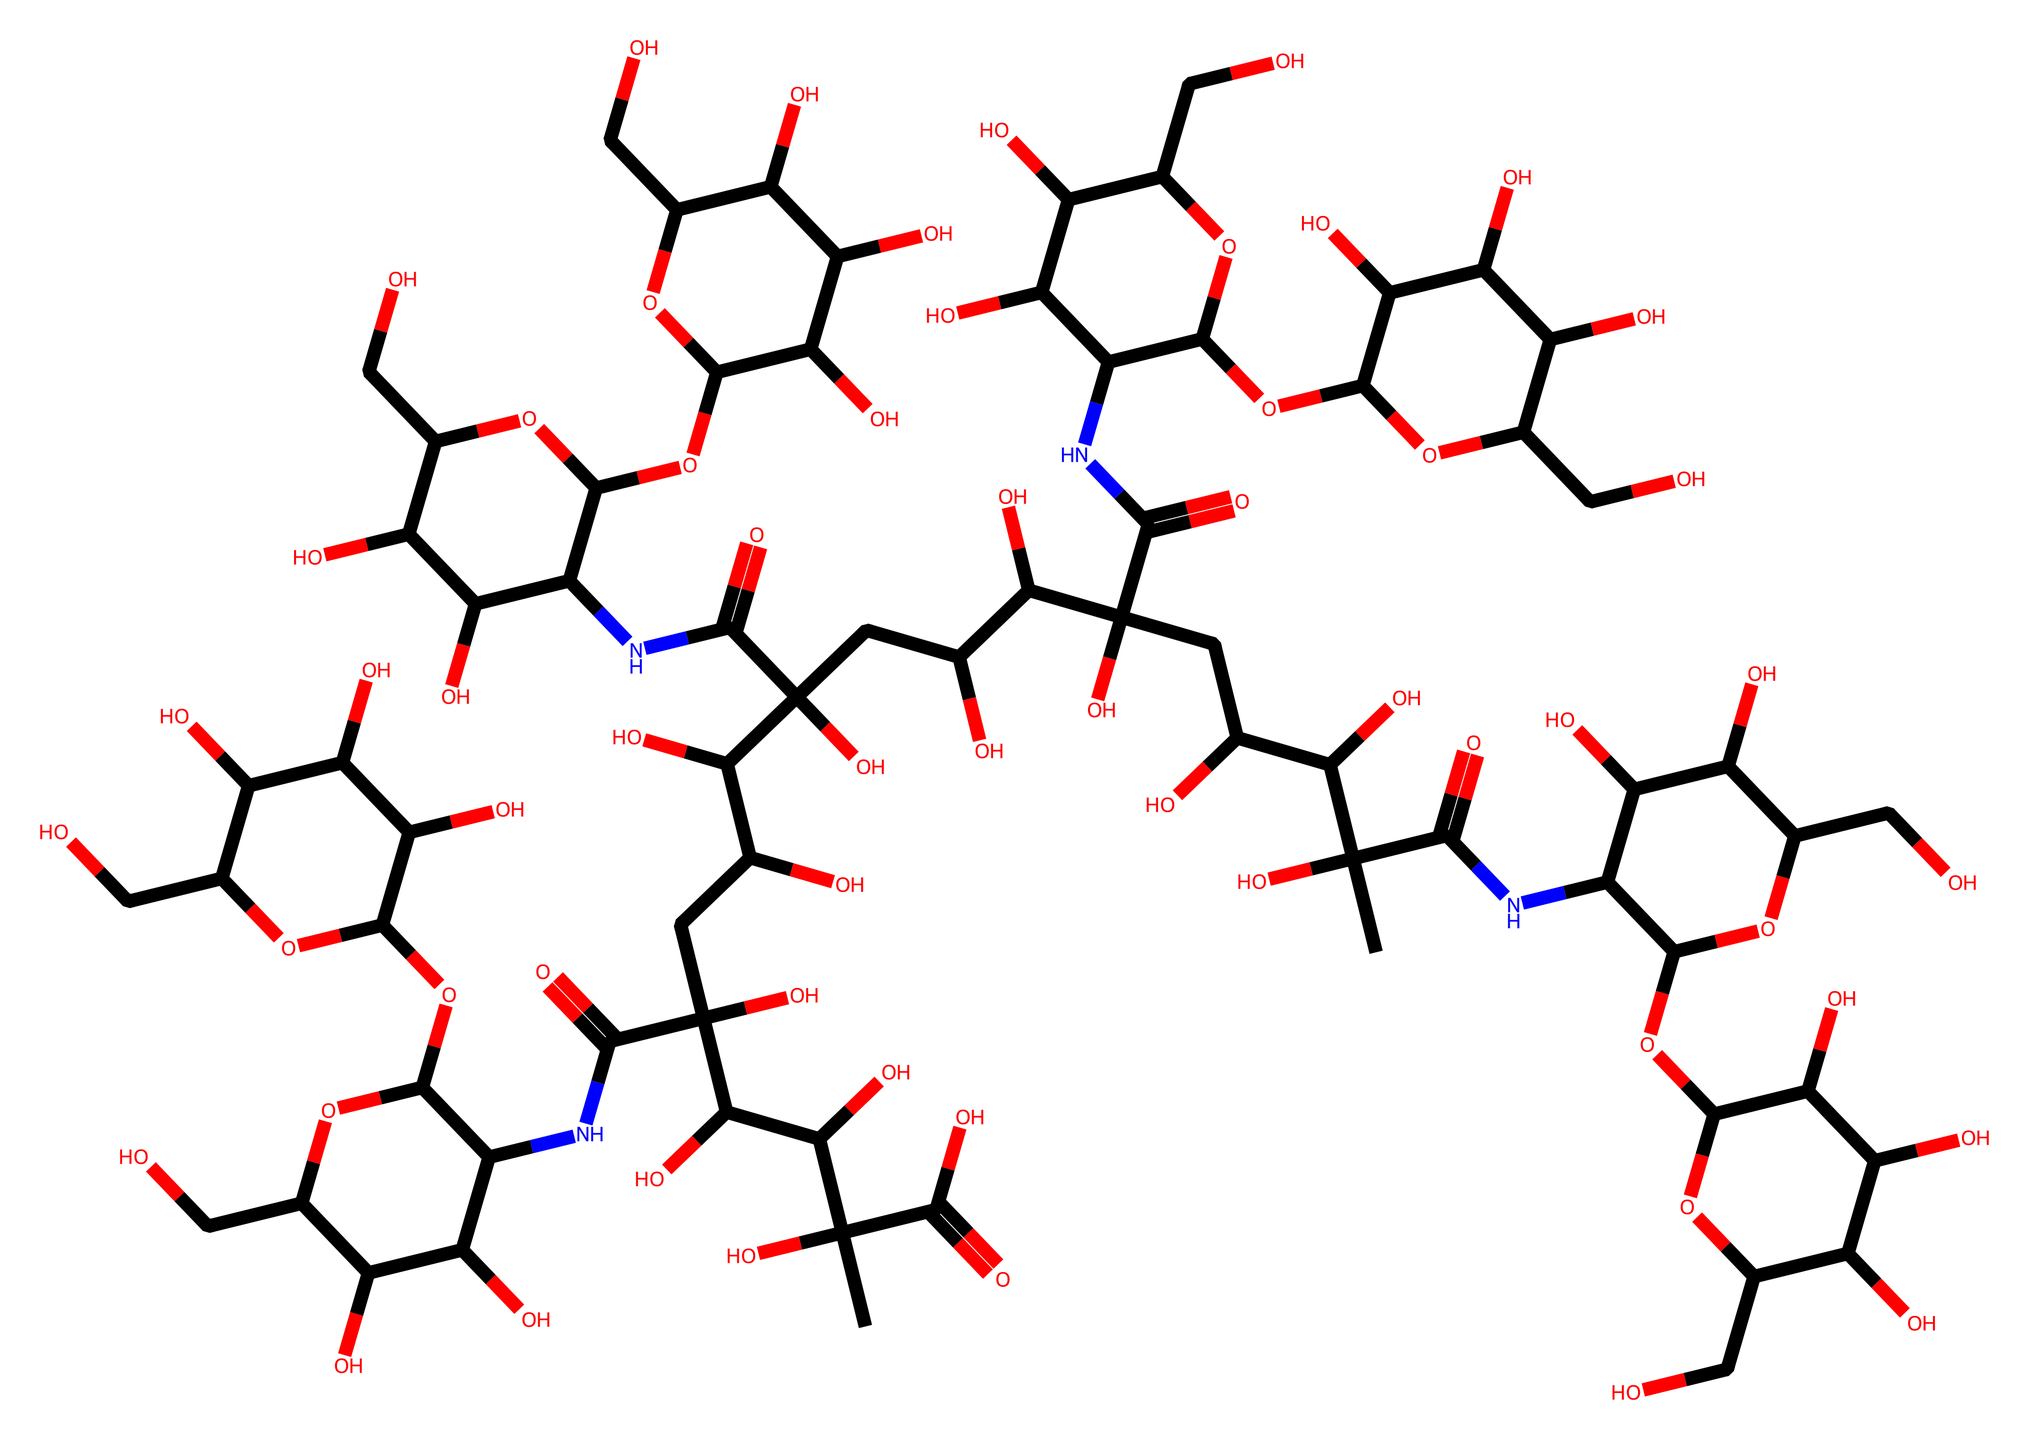What is the main type of functional groups present in hyaluronic acid? The structural formula shows multiple hydroxyl groups (-OH) and carboxylic acid groups (-COOH), which are key functional groups in hyaluronic acid.
Answer: hydroxyl and carboxylic acid How many rings are present in the structure of hyaluronic acid? Upon examining the SMILES notation, we can identify that there are several cyclic structures in the form of connected rings, specifically the presence of C1, C3, C5, C7, and C8 indicates multiple rings.
Answer: five What is the molecular weight estimate of hyaluronic acid based on its composition? While the exact calculation requires determining the number of each atom, the overall structure suggests it is a large biopolymer, with a typical molecular weight range of about 1000 kDa to 1,500 kDa for hyaluronic acid.
Answer: around 1000 kDa Which type of bonding is predominantly responsible for the strength of hyaluronic acid? The repeated amide linkages and hydrogen bonding between hydroxyl groups in the structure contribute to the strength and viscosity of hyaluronic acid.
Answer: hydrogen bonding What role does the carboxylic acid group play in the properties of hyaluronic acid? The carboxylic acid groups can donate protons and participate in ionic interactions, which increase water retention and contribute to the gel-like consistency of hyaluronic acid in cosmetic formulations.
Answer: water retention How many different types of sugar units can be found in hyaluronic acid? The structure can be inferred to consist of repeating disaccharide units, which are alternating glucuronic acid and N-acetylglucosamine. Thus, there are two types of sugar units.
Answer: two 